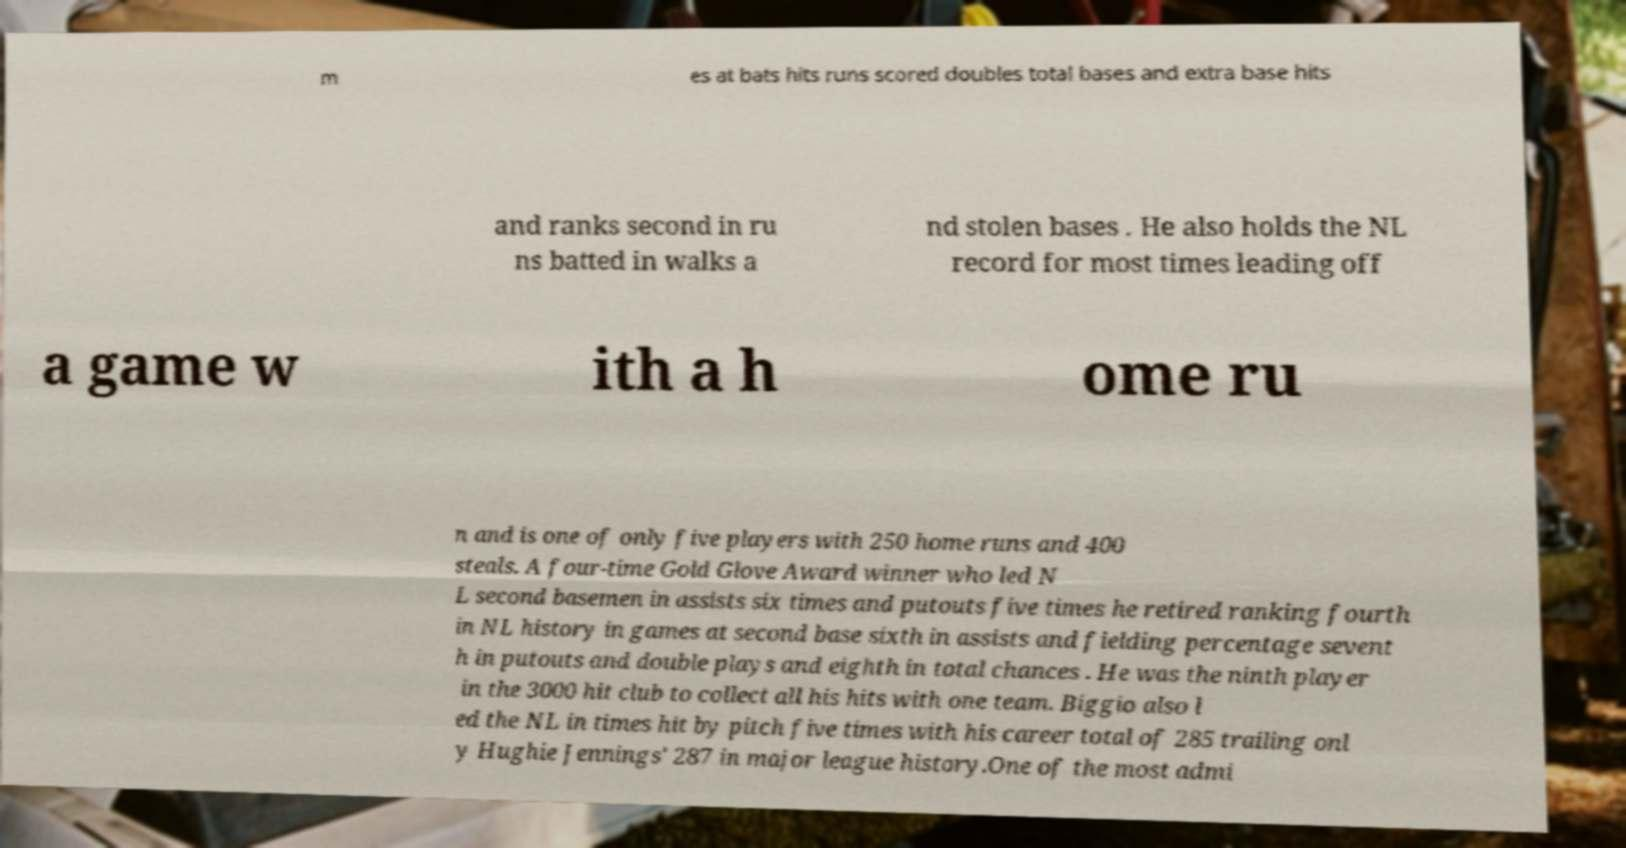Please identify and transcribe the text found in this image. m es at bats hits runs scored doubles total bases and extra base hits and ranks second in ru ns batted in walks a nd stolen bases . He also holds the NL record for most times leading off a game w ith a h ome ru n and is one of only five players with 250 home runs and 400 steals. A four-time Gold Glove Award winner who led N L second basemen in assists six times and putouts five times he retired ranking fourth in NL history in games at second base sixth in assists and fielding percentage sevent h in putouts and double plays and eighth in total chances . He was the ninth player in the 3000 hit club to collect all his hits with one team. Biggio also l ed the NL in times hit by pitch five times with his career total of 285 trailing onl y Hughie Jennings' 287 in major league history.One of the most admi 